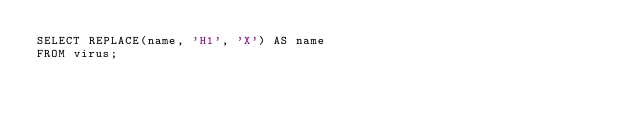<code> <loc_0><loc_0><loc_500><loc_500><_SQL_>SELECT REPLACE(name, 'H1', 'X') AS name
FROM virus;</code> 